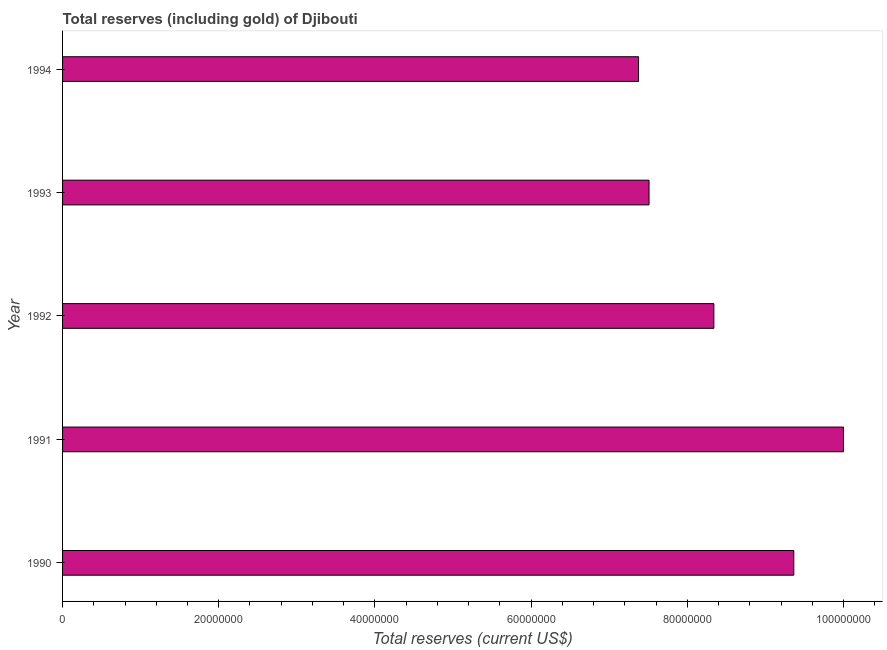Does the graph contain any zero values?
Your answer should be very brief. No. What is the title of the graph?
Offer a very short reply. Total reserves (including gold) of Djibouti. What is the label or title of the X-axis?
Your answer should be very brief. Total reserves (current US$). What is the label or title of the Y-axis?
Provide a short and direct response. Year. What is the total reserves (including gold) in 1993?
Your response must be concise. 7.51e+07. Across all years, what is the maximum total reserves (including gold)?
Offer a very short reply. 1.00e+08. Across all years, what is the minimum total reserves (including gold)?
Offer a terse response. 7.38e+07. In which year was the total reserves (including gold) maximum?
Your answer should be very brief. 1991. In which year was the total reserves (including gold) minimum?
Ensure brevity in your answer.  1994. What is the sum of the total reserves (including gold)?
Keep it short and to the point. 4.26e+08. What is the difference between the total reserves (including gold) in 1992 and 1994?
Provide a succinct answer. 9.64e+06. What is the average total reserves (including gold) per year?
Make the answer very short. 8.52e+07. What is the median total reserves (including gold)?
Ensure brevity in your answer.  8.34e+07. In how many years, is the total reserves (including gold) greater than 72000000 US$?
Provide a succinct answer. 5. What is the ratio of the total reserves (including gold) in 1992 to that in 1994?
Keep it short and to the point. 1.13. Is the difference between the total reserves (including gold) in 1993 and 1994 greater than the difference between any two years?
Offer a terse response. No. What is the difference between the highest and the second highest total reserves (including gold)?
Offer a terse response. 6.36e+06. Is the sum of the total reserves (including gold) in 1990 and 1991 greater than the maximum total reserves (including gold) across all years?
Your response must be concise. Yes. What is the difference between the highest and the lowest total reserves (including gold)?
Provide a succinct answer. 2.62e+07. How many bars are there?
Make the answer very short. 5. What is the Total reserves (current US$) in 1990?
Give a very brief answer. 9.36e+07. What is the Total reserves (current US$) of 1991?
Offer a terse response. 1.00e+08. What is the Total reserves (current US$) in 1992?
Provide a short and direct response. 8.34e+07. What is the Total reserves (current US$) of 1993?
Ensure brevity in your answer.  7.51e+07. What is the Total reserves (current US$) in 1994?
Your response must be concise. 7.38e+07. What is the difference between the Total reserves (current US$) in 1990 and 1991?
Offer a terse response. -6.36e+06. What is the difference between the Total reserves (current US$) in 1990 and 1992?
Your answer should be compact. 1.02e+07. What is the difference between the Total reserves (current US$) in 1990 and 1993?
Your answer should be compact. 1.85e+07. What is the difference between the Total reserves (current US$) in 1990 and 1994?
Provide a succinct answer. 1.99e+07. What is the difference between the Total reserves (current US$) in 1991 and 1992?
Make the answer very short. 1.66e+07. What is the difference between the Total reserves (current US$) in 1991 and 1993?
Your answer should be compact. 2.49e+07. What is the difference between the Total reserves (current US$) in 1991 and 1994?
Your answer should be compact. 2.62e+07. What is the difference between the Total reserves (current US$) in 1992 and 1993?
Give a very brief answer. 8.30e+06. What is the difference between the Total reserves (current US$) in 1992 and 1994?
Your response must be concise. 9.64e+06. What is the difference between the Total reserves (current US$) in 1993 and 1994?
Make the answer very short. 1.34e+06. What is the ratio of the Total reserves (current US$) in 1990 to that in 1991?
Your answer should be very brief. 0.94. What is the ratio of the Total reserves (current US$) in 1990 to that in 1992?
Keep it short and to the point. 1.12. What is the ratio of the Total reserves (current US$) in 1990 to that in 1993?
Give a very brief answer. 1.25. What is the ratio of the Total reserves (current US$) in 1990 to that in 1994?
Your answer should be very brief. 1.27. What is the ratio of the Total reserves (current US$) in 1991 to that in 1992?
Your answer should be very brief. 1.2. What is the ratio of the Total reserves (current US$) in 1991 to that in 1993?
Provide a short and direct response. 1.33. What is the ratio of the Total reserves (current US$) in 1991 to that in 1994?
Provide a succinct answer. 1.36. What is the ratio of the Total reserves (current US$) in 1992 to that in 1993?
Keep it short and to the point. 1.11. What is the ratio of the Total reserves (current US$) in 1992 to that in 1994?
Offer a terse response. 1.13. What is the ratio of the Total reserves (current US$) in 1993 to that in 1994?
Your answer should be compact. 1.02. 